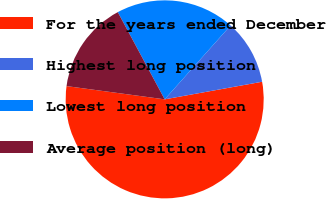<chart> <loc_0><loc_0><loc_500><loc_500><pie_chart><fcel>For the years ended December<fcel>Highest long position<fcel>Lowest long position<fcel>Average position (long)<nl><fcel>54.98%<fcel>10.56%<fcel>19.45%<fcel>15.01%<nl></chart> 